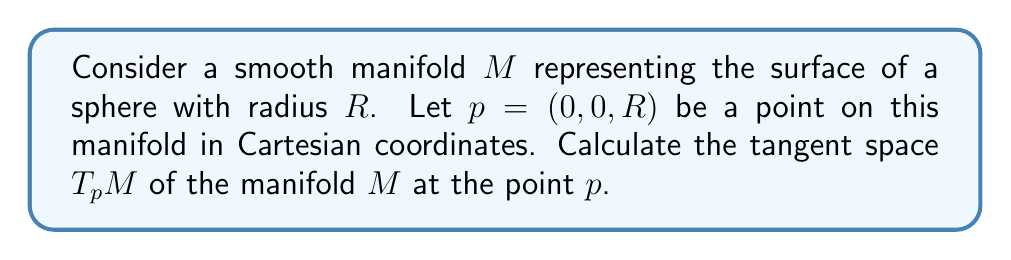Solve this math problem. To calculate the tangent space of a smooth manifold at a given point, we need to follow these steps:

1. Identify the manifold and its parametrization:
   The sphere can be parametrized using spherical coordinates:
   $$\mathbf{r}(\theta, \phi) = (R\sin\theta\cos\phi, R\sin\theta\sin\phi, R\cos\theta)$$
   where $0 \leq \theta \leq \pi$ and $0 \leq \phi < 2\pi$.

2. Find the point $p$ in terms of the parameters:
   The point $p = (0, 0, R)$ corresponds to $\theta = 0$ and $\phi = 0$.

3. Calculate the partial derivatives with respect to $\theta$ and $\phi$:
   $$\frac{\partial \mathbf{r}}{\partial \theta} = (R\cos\theta\cos\phi, R\cos\theta\sin\phi, -R\sin\theta)$$
   $$\frac{\partial \mathbf{r}}{\partial \phi} = (-R\sin\theta\sin\phi, R\sin\theta\cos\phi, 0)$$

4. Evaluate these partial derivatives at the point $p$ (i.e., at $\theta = 0$, $\phi = 0$):
   $$\left.\frac{\partial \mathbf{r}}{\partial \theta}\right|_p = (R, 0, 0)$$
   $$\left.\frac{\partial \mathbf{r}}{\partial \phi}\right|_p = (0, R, 0)$$

5. The tangent space $T_p M$ is the span of these two vectors:
   $$T_p M = \text{span}\{(R, 0, 0), (0, R, 0)\}$$

This result aligns with our intuition: the tangent space at the "north pole" of a sphere is the $xy$-plane tangent to the sphere at that point.
Answer: The tangent space of the manifold $M$ at the point $p = (0, 0, R)$ is:
$$T_p M = \text{span}\{(R, 0, 0), (0, R, 0)\}$$
This represents the $xy$-plane tangent to the sphere at the point $(0, 0, R)$. 